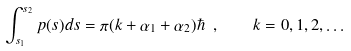<formula> <loc_0><loc_0><loc_500><loc_500>\int ^ { s _ { 2 } } _ { s _ { 1 } } { p } ( s ) d s = \pi ( k + \alpha _ { 1 } + \alpha _ { 2 } ) \hbar { \ } , \quad k = 0 , 1 , 2 , \dots</formula> 